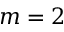<formula> <loc_0><loc_0><loc_500><loc_500>m = 2</formula> 